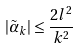<formula> <loc_0><loc_0><loc_500><loc_500>| \tilde { \alpha } _ { k } | \leq \frac { 2 l ^ { 2 } } { k ^ { 2 } }</formula> 